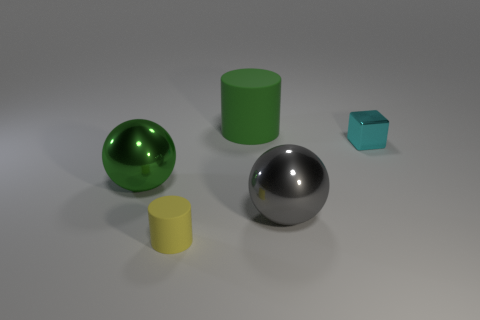Subtract all brown cubes. Subtract all cyan spheres. How many cubes are left? 1 Add 3 green matte objects. How many objects exist? 8 Subtract all cylinders. How many objects are left? 3 Subtract 1 gray balls. How many objects are left? 4 Subtract all gray balls. Subtract all green rubber cylinders. How many objects are left? 3 Add 3 matte cylinders. How many matte cylinders are left? 5 Add 1 cubes. How many cubes exist? 2 